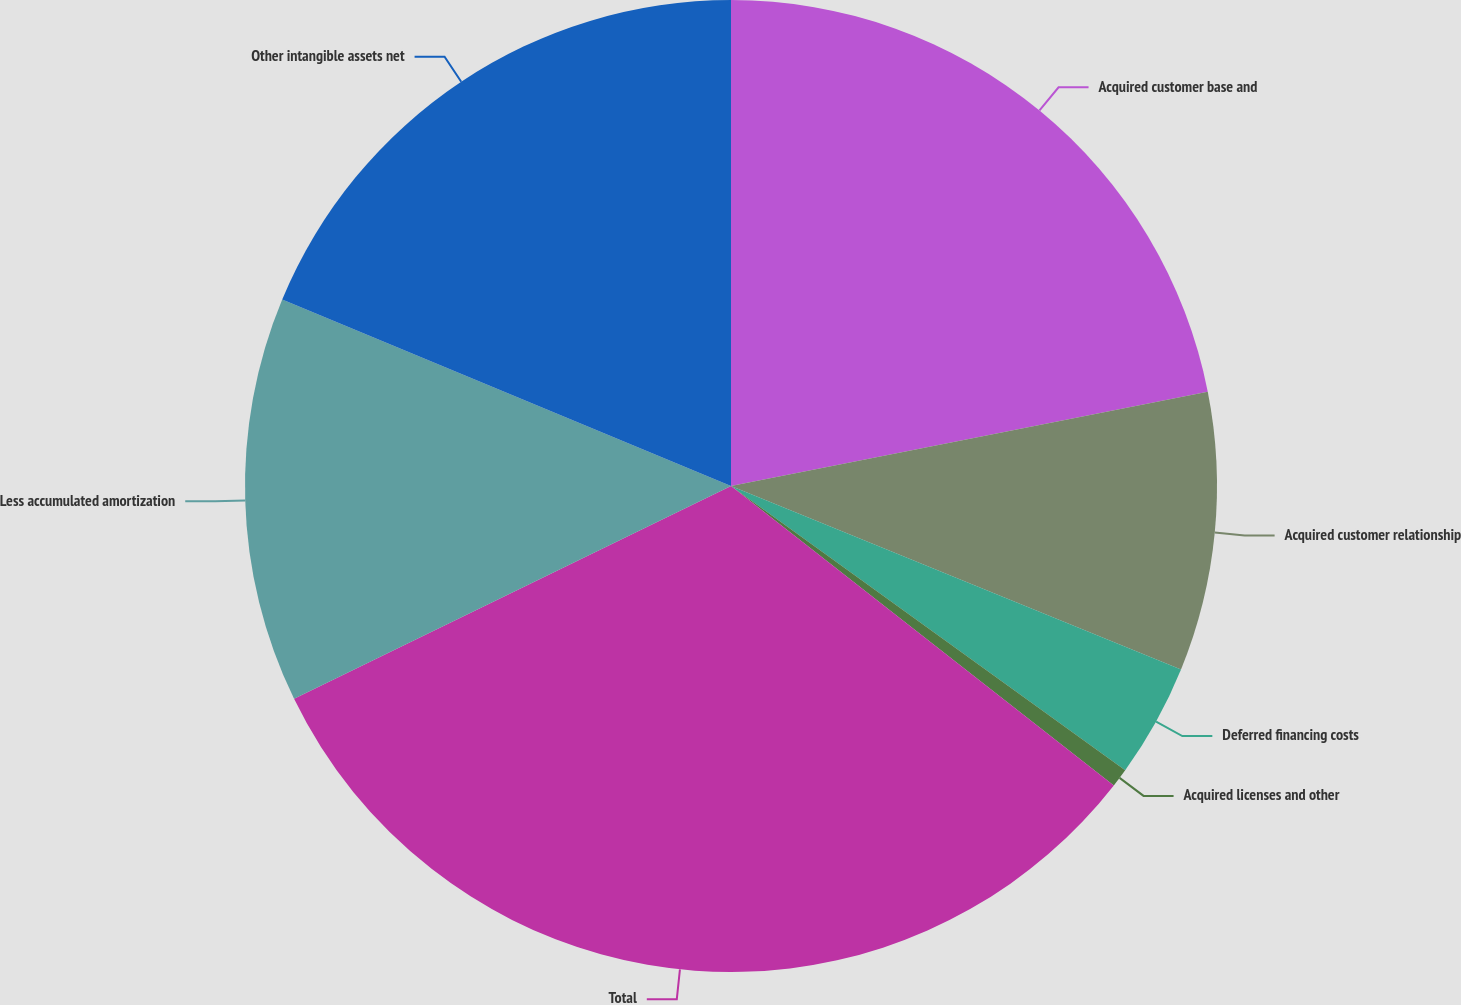<chart> <loc_0><loc_0><loc_500><loc_500><pie_chart><fcel>Acquired customer base and<fcel>Acquired customer relationship<fcel>Deferred financing costs<fcel>Acquired licenses and other<fcel>Total<fcel>Less accumulated amortization<fcel>Other intangible assets net<nl><fcel>21.89%<fcel>9.27%<fcel>3.78%<fcel>0.62%<fcel>32.22%<fcel>13.48%<fcel>18.73%<nl></chart> 